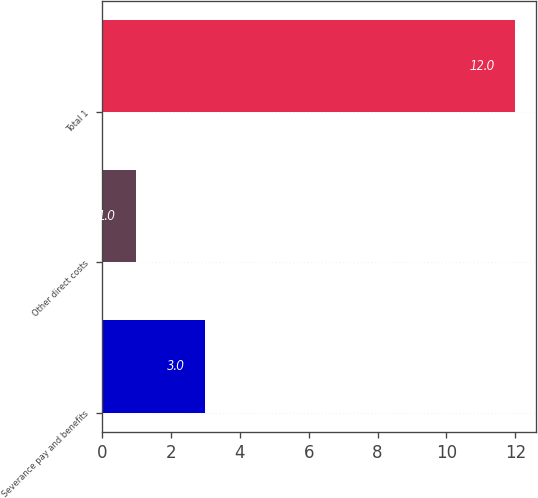Convert chart. <chart><loc_0><loc_0><loc_500><loc_500><bar_chart><fcel>Severance pay and benefits<fcel>Other direct costs<fcel>Total 1<nl><fcel>3<fcel>1<fcel>12<nl></chart> 